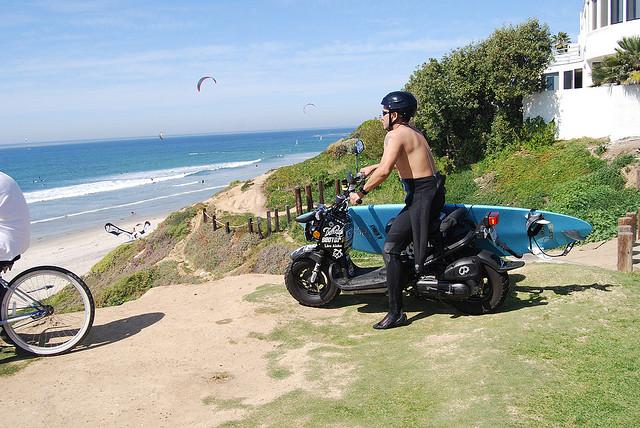Would this be a fun place to go swimming?
Be succinct. Yes. What is the weather?
Quick response, please. Sunny. How many types of bikes are there?
Short answer required. 2. Where is this body of water located?
Concise answer only. Beach. Is there a scooter?
Short answer required. Yes. 